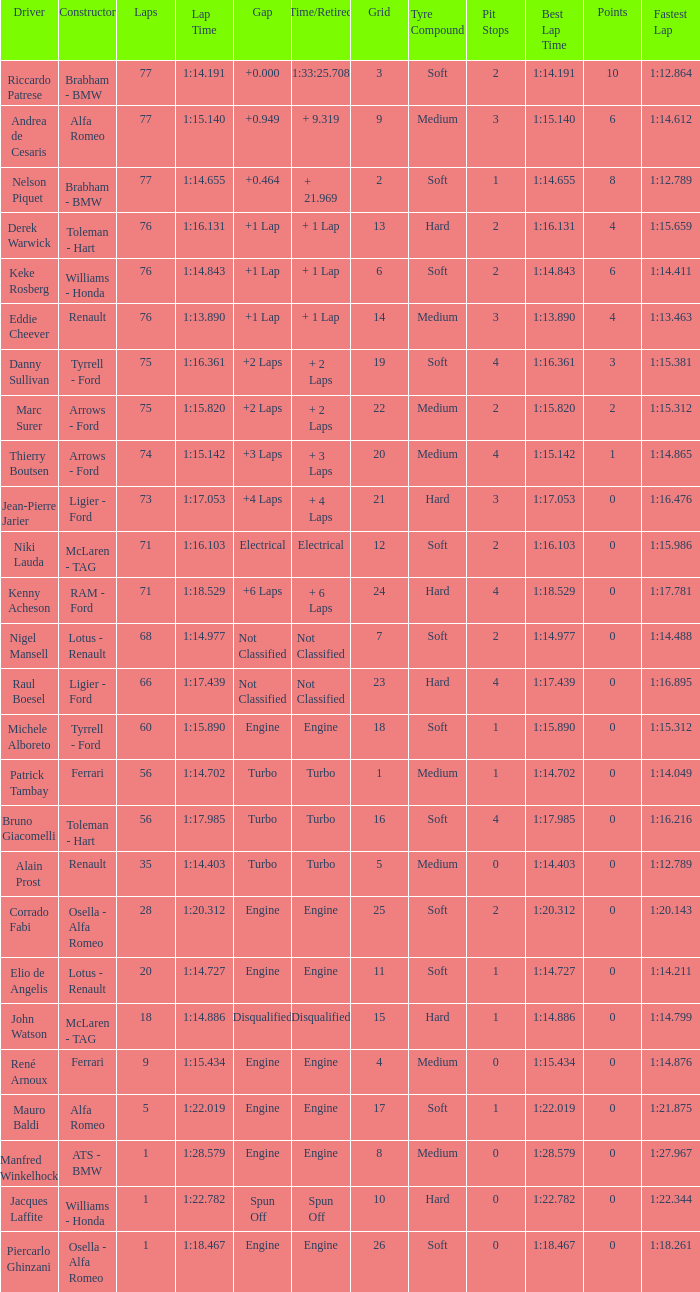Parse the full table. {'header': ['Driver', 'Constructor', 'Laps', 'Lap Time', 'Gap', 'Time/Retired', 'Grid', 'Tyre Compound', 'Pit Stops', 'Best Lap Time', 'Points', 'Fastest Lap'], 'rows': [['Riccardo Patrese', 'Brabham - BMW', '77', '1:14.191', '+0.000', '1:33:25.708', '3', 'Soft', '2', '1:14.191', '10', '1:12.864'], ['Andrea de Cesaris', 'Alfa Romeo', '77', '1:15.140', '+0.949', '+ 9.319', '9', 'Medium', '3', '1:15.140', '6', '1:14.612'], ['Nelson Piquet', 'Brabham - BMW', '77', '1:14.655', '+0.464', '+ 21.969', '2', 'Soft', '1', '1:14.655', '8', '1:12.789'], ['Derek Warwick', 'Toleman - Hart', '76', '1:16.131', '+1 Lap', '+ 1 Lap', '13', 'Hard', '2', '1:16.131', '4', '1:15.659'], ['Keke Rosberg', 'Williams - Honda', '76', '1:14.843', '+1 Lap', '+ 1 Lap', '6', 'Soft', '2', '1:14.843', '6', '1:14.411'], ['Eddie Cheever', 'Renault', '76', '1:13.890', '+1 Lap', '+ 1 Lap', '14', 'Medium', '3', '1:13.890', '4', '1:13.463'], ['Danny Sullivan', 'Tyrrell - Ford', '75', '1:16.361', '+2 Laps', '+ 2 Laps', '19', 'Soft', '4', '1:16.361', '3', '1:15.381'], ['Marc Surer', 'Arrows - Ford', '75', '1:15.820', '+2 Laps', '+ 2 Laps', '22', 'Medium', '2', '1:15.820', '2', '1:15.312'], ['Thierry Boutsen', 'Arrows - Ford', '74', '1:15.142', '+3 Laps', '+ 3 Laps', '20', 'Medium', '4', '1:15.142', '1', '1:14.865'], ['Jean-Pierre Jarier', 'Ligier - Ford', '73', '1:17.053', '+4 Laps', '+ 4 Laps', '21', 'Hard', '3', '1:17.053', '0', '1:16.476'], ['Niki Lauda', 'McLaren - TAG', '71', '1:16.103', 'Electrical', 'Electrical', '12', 'Soft', '2', '1:16.103', '0', '1:15.986'], ['Kenny Acheson', 'RAM - Ford', '71', '1:18.529', '+6 Laps', '+ 6 Laps', '24', 'Hard', '4', '1:18.529', '0', '1:17.781'], ['Nigel Mansell', 'Lotus - Renault', '68', '1:14.977', 'Not Classified', 'Not Classified', '7', 'Soft', '2', '1:14.977', '0', '1:14.488'], ['Raul Boesel', 'Ligier - Ford', '66', '1:17.439', 'Not Classified', 'Not Classified', '23', 'Hard', '4', '1:17.439', '0', '1:16.895'], ['Michele Alboreto', 'Tyrrell - Ford', '60', '1:15.890', 'Engine', 'Engine', '18', 'Soft', '1', '1:15.890', '0', '1:15.312'], ['Patrick Tambay', 'Ferrari', '56', '1:14.702', 'Turbo', 'Turbo', '1', 'Medium', '1', '1:14.702', '0', '1:14.049'], ['Bruno Giacomelli', 'Toleman - Hart', '56', '1:17.985', 'Turbo', 'Turbo', '16', 'Soft', '4', '1:17.985', '0', '1:16.216'], ['Alain Prost', 'Renault', '35', '1:14.403', 'Turbo', 'Turbo', '5', 'Medium', '0', '1:14.403', '0', '1:12.789'], ['Corrado Fabi', 'Osella - Alfa Romeo', '28', '1:20.312', 'Engine', 'Engine', '25', 'Soft', '2', '1:20.312', '0', '1:20.143'], ['Elio de Angelis', 'Lotus - Renault', '20', '1:14.727', 'Engine', 'Engine', '11', 'Soft', '1', '1:14.727', '0', '1:14.211'], ['John Watson', 'McLaren - TAG', '18', '1:14.886', 'Disqualified', 'Disqualified', '15', 'Hard', '1', '1:14.886', '0', '1:14.799'], ['René Arnoux', 'Ferrari', '9', '1:15.434', 'Engine', 'Engine', '4', 'Medium', '0', '1:15.434', '0', '1:14.876'], ['Mauro Baldi', 'Alfa Romeo', '5', '1:22.019', 'Engine', 'Engine', '17', 'Soft', '1', '1:22.019', '0', '1:21.875'], ['Manfred Winkelhock', 'ATS - BMW', '1', '1:28.579', 'Engine', 'Engine', '8', 'Medium', '0', '1:28.579', '0', '1:27.967'], ['Jacques Laffite', 'Williams - Honda', '1', '1:22.782', 'Spun Off', 'Spun Off', '10', 'Hard', '0', '1:22.782', '0', '1:22.344'], ['Piercarlo Ghinzani', 'Osella - Alfa Romeo', '1', '1:18.467', 'Engine', 'Engine', '26', 'Soft', '0', '1:18.467', '0', '1:18.261']]} Who drove the grid 10 car? Jacques Laffite. 